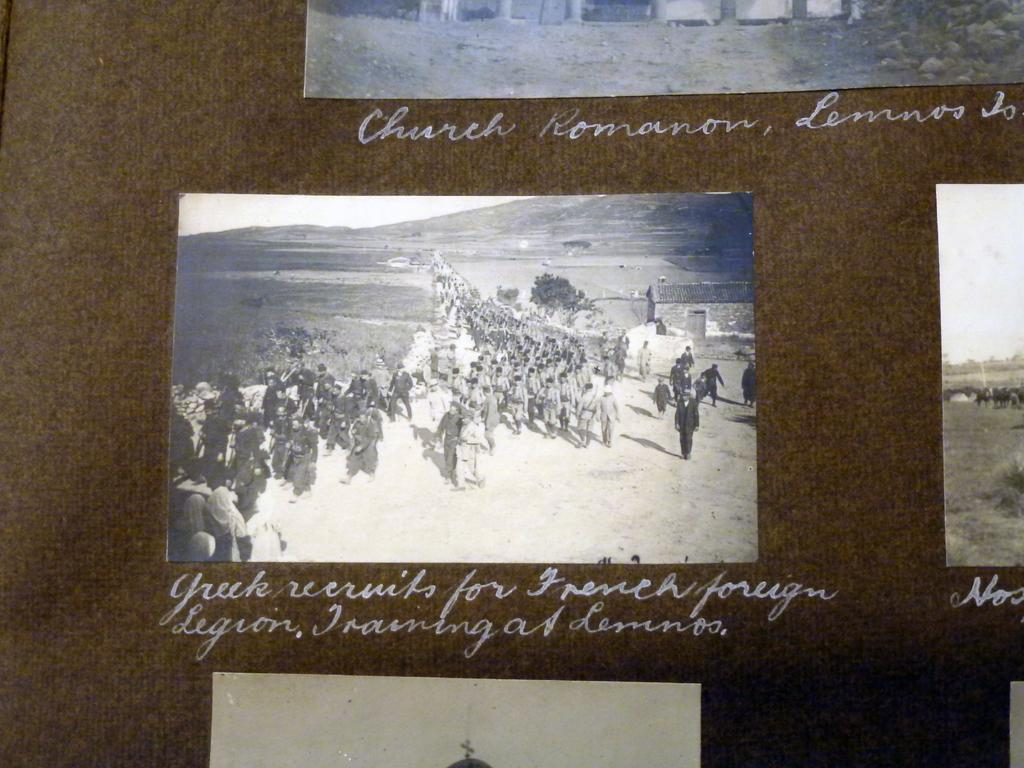What is the color of the object that has papers attached to it? The object is brown in color. What can be seen on the object with the papers attached? There is something written in white color in the image. What type of calculator is visible in the image? There is no calculator present in the image. Can you tell me how many times the object is flipped over in the image? The image does not show the object being flipped over, so it cannot be determined how many times it is flipped. 